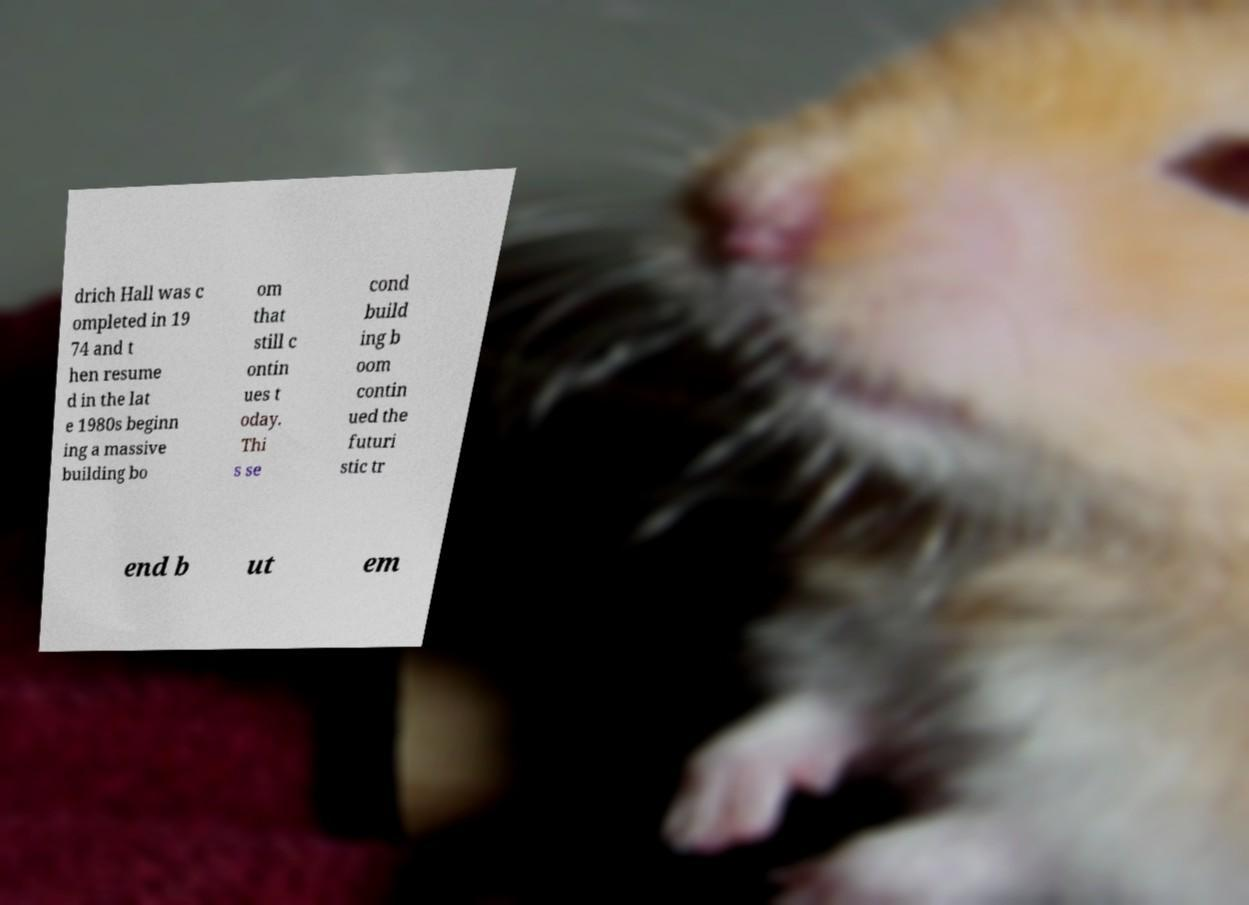Can you accurately transcribe the text from the provided image for me? drich Hall was c ompleted in 19 74 and t hen resume d in the lat e 1980s beginn ing a massive building bo om that still c ontin ues t oday. Thi s se cond build ing b oom contin ued the futuri stic tr end b ut em 